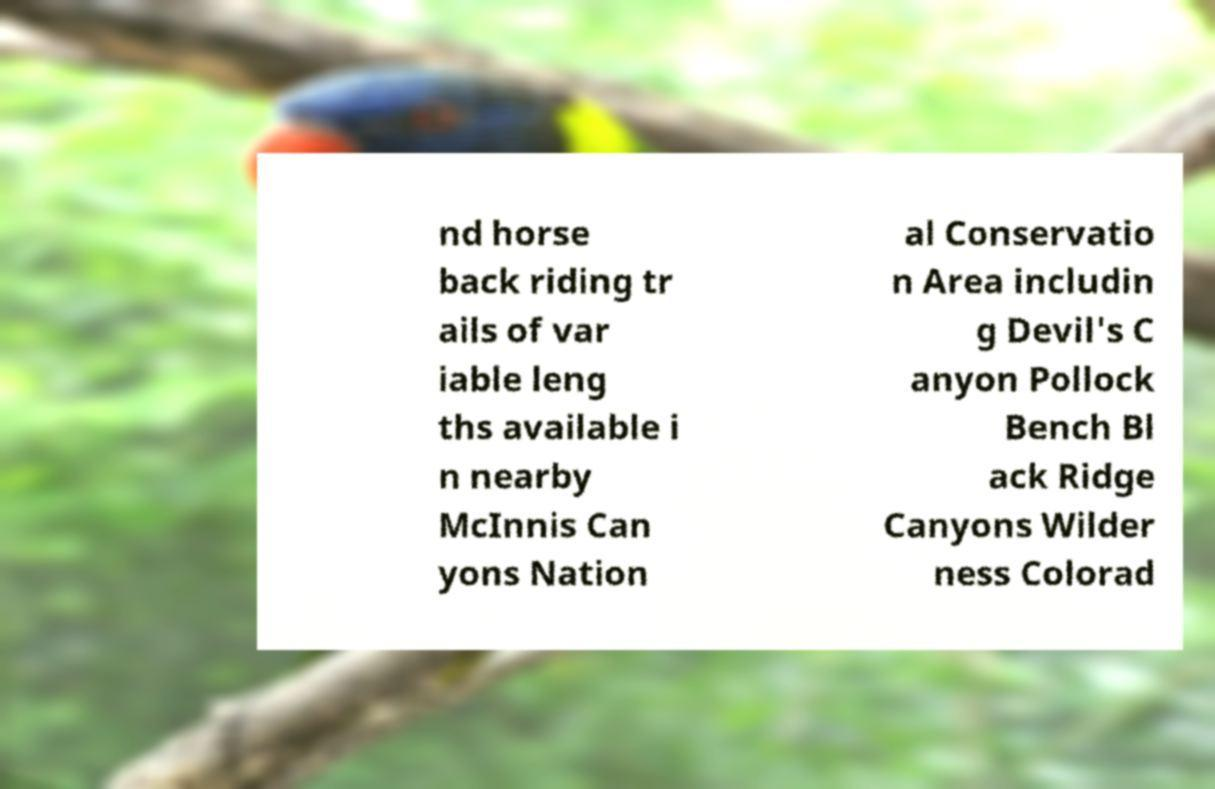What messages or text are displayed in this image? I need them in a readable, typed format. nd horse back riding tr ails of var iable leng ths available i n nearby McInnis Can yons Nation al Conservatio n Area includin g Devil's C anyon Pollock Bench Bl ack Ridge Canyons Wilder ness Colorad 